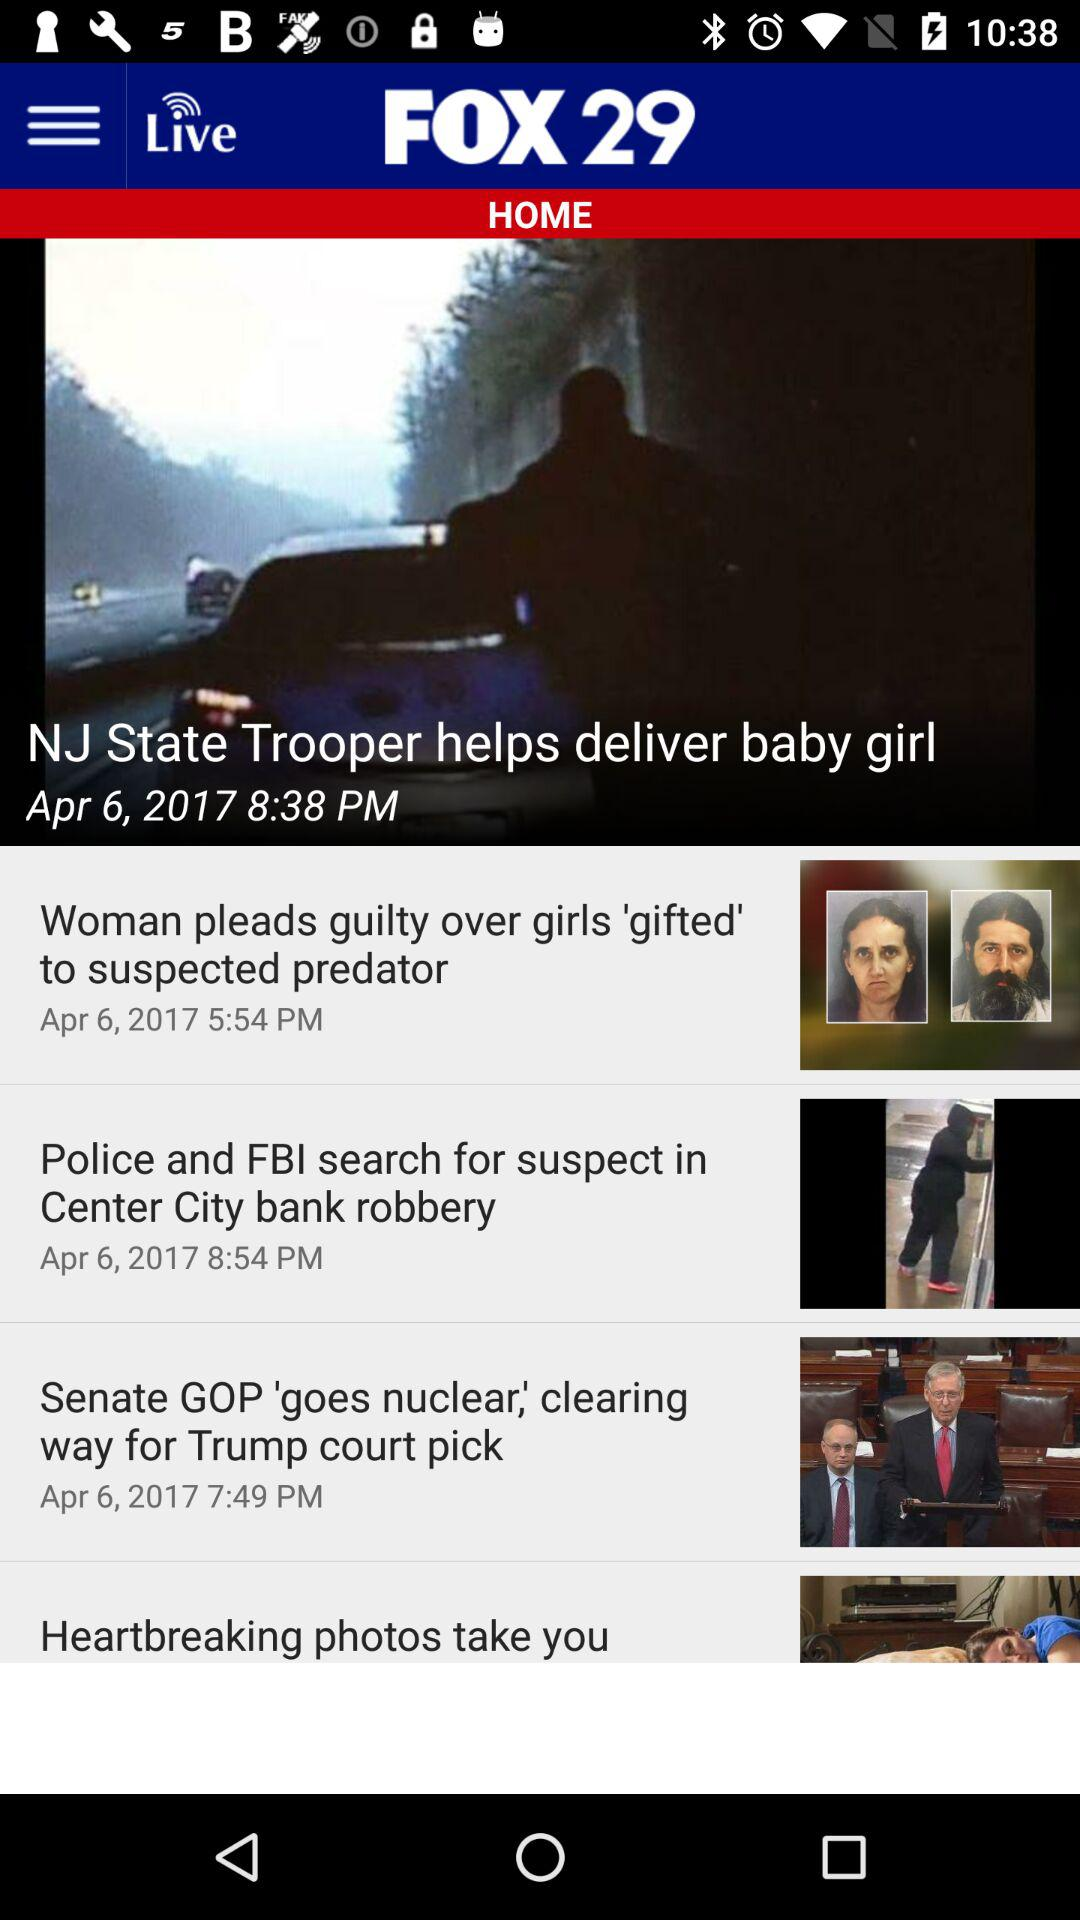When was the news "Heartbreaking photos take you" posted?
When the provided information is insufficient, respond with <no answer>. <no answer> 